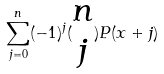<formula> <loc_0><loc_0><loc_500><loc_500>\sum _ { j = 0 } ^ { n } ( - 1 ) ^ { j } ( \begin{matrix} n \\ j \end{matrix} ) P ( x + j )</formula> 